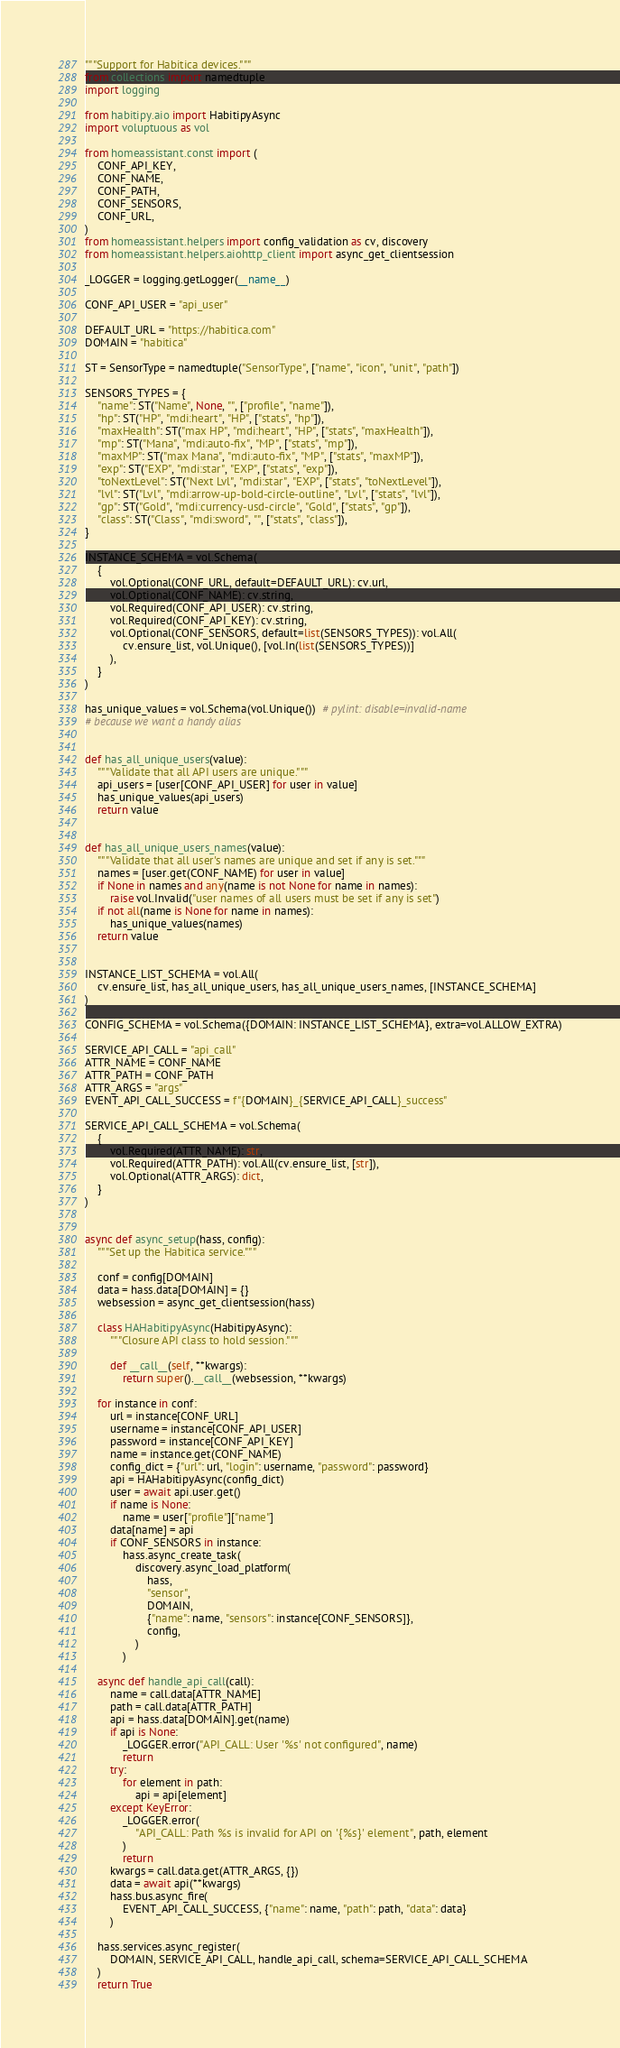Convert code to text. <code><loc_0><loc_0><loc_500><loc_500><_Python_>"""Support for Habitica devices."""
from collections import namedtuple
import logging

from habitipy.aio import HabitipyAsync
import voluptuous as vol

from homeassistant.const import (
    CONF_API_KEY,
    CONF_NAME,
    CONF_PATH,
    CONF_SENSORS,
    CONF_URL,
)
from homeassistant.helpers import config_validation as cv, discovery
from homeassistant.helpers.aiohttp_client import async_get_clientsession

_LOGGER = logging.getLogger(__name__)

CONF_API_USER = "api_user"

DEFAULT_URL = "https://habitica.com"
DOMAIN = "habitica"

ST = SensorType = namedtuple("SensorType", ["name", "icon", "unit", "path"])

SENSORS_TYPES = {
    "name": ST("Name", None, "", ["profile", "name"]),
    "hp": ST("HP", "mdi:heart", "HP", ["stats", "hp"]),
    "maxHealth": ST("max HP", "mdi:heart", "HP", ["stats", "maxHealth"]),
    "mp": ST("Mana", "mdi:auto-fix", "MP", ["stats", "mp"]),
    "maxMP": ST("max Mana", "mdi:auto-fix", "MP", ["stats", "maxMP"]),
    "exp": ST("EXP", "mdi:star", "EXP", ["stats", "exp"]),
    "toNextLevel": ST("Next Lvl", "mdi:star", "EXP", ["stats", "toNextLevel"]),
    "lvl": ST("Lvl", "mdi:arrow-up-bold-circle-outline", "Lvl", ["stats", "lvl"]),
    "gp": ST("Gold", "mdi:currency-usd-circle", "Gold", ["stats", "gp"]),
    "class": ST("Class", "mdi:sword", "", ["stats", "class"]),
}

INSTANCE_SCHEMA = vol.Schema(
    {
        vol.Optional(CONF_URL, default=DEFAULT_URL): cv.url,
        vol.Optional(CONF_NAME): cv.string,
        vol.Required(CONF_API_USER): cv.string,
        vol.Required(CONF_API_KEY): cv.string,
        vol.Optional(CONF_SENSORS, default=list(SENSORS_TYPES)): vol.All(
            cv.ensure_list, vol.Unique(), [vol.In(list(SENSORS_TYPES))]
        ),
    }
)

has_unique_values = vol.Schema(vol.Unique())  # pylint: disable=invalid-name
# because we want a handy alias


def has_all_unique_users(value):
    """Validate that all API users are unique."""
    api_users = [user[CONF_API_USER] for user in value]
    has_unique_values(api_users)
    return value


def has_all_unique_users_names(value):
    """Validate that all user's names are unique and set if any is set."""
    names = [user.get(CONF_NAME) for user in value]
    if None in names and any(name is not None for name in names):
        raise vol.Invalid("user names of all users must be set if any is set")
    if not all(name is None for name in names):
        has_unique_values(names)
    return value


INSTANCE_LIST_SCHEMA = vol.All(
    cv.ensure_list, has_all_unique_users, has_all_unique_users_names, [INSTANCE_SCHEMA]
)

CONFIG_SCHEMA = vol.Schema({DOMAIN: INSTANCE_LIST_SCHEMA}, extra=vol.ALLOW_EXTRA)

SERVICE_API_CALL = "api_call"
ATTR_NAME = CONF_NAME
ATTR_PATH = CONF_PATH
ATTR_ARGS = "args"
EVENT_API_CALL_SUCCESS = f"{DOMAIN}_{SERVICE_API_CALL}_success"

SERVICE_API_CALL_SCHEMA = vol.Schema(
    {
        vol.Required(ATTR_NAME): str,
        vol.Required(ATTR_PATH): vol.All(cv.ensure_list, [str]),
        vol.Optional(ATTR_ARGS): dict,
    }
)


async def async_setup(hass, config):
    """Set up the Habitica service."""

    conf = config[DOMAIN]
    data = hass.data[DOMAIN] = {}
    websession = async_get_clientsession(hass)

    class HAHabitipyAsync(HabitipyAsync):
        """Closure API class to hold session."""

        def __call__(self, **kwargs):
            return super().__call__(websession, **kwargs)

    for instance in conf:
        url = instance[CONF_URL]
        username = instance[CONF_API_USER]
        password = instance[CONF_API_KEY]
        name = instance.get(CONF_NAME)
        config_dict = {"url": url, "login": username, "password": password}
        api = HAHabitipyAsync(config_dict)
        user = await api.user.get()
        if name is None:
            name = user["profile"]["name"]
        data[name] = api
        if CONF_SENSORS in instance:
            hass.async_create_task(
                discovery.async_load_platform(
                    hass,
                    "sensor",
                    DOMAIN,
                    {"name": name, "sensors": instance[CONF_SENSORS]},
                    config,
                )
            )

    async def handle_api_call(call):
        name = call.data[ATTR_NAME]
        path = call.data[ATTR_PATH]
        api = hass.data[DOMAIN].get(name)
        if api is None:
            _LOGGER.error("API_CALL: User '%s' not configured", name)
            return
        try:
            for element in path:
                api = api[element]
        except KeyError:
            _LOGGER.error(
                "API_CALL: Path %s is invalid for API on '{%s}' element", path, element
            )
            return
        kwargs = call.data.get(ATTR_ARGS, {})
        data = await api(**kwargs)
        hass.bus.async_fire(
            EVENT_API_CALL_SUCCESS, {"name": name, "path": path, "data": data}
        )

    hass.services.async_register(
        DOMAIN, SERVICE_API_CALL, handle_api_call, schema=SERVICE_API_CALL_SCHEMA
    )
    return True
</code> 